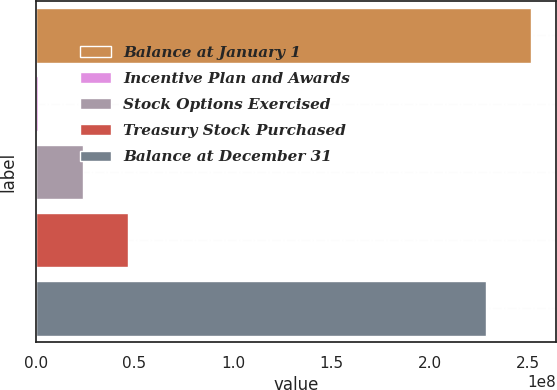Convert chart. <chart><loc_0><loc_0><loc_500><loc_500><bar_chart><fcel>Balance at January 1<fcel>Incentive Plan and Awards<fcel>Stock Options Exercised<fcel>Treasury Stock Purchased<fcel>Balance at December 31<nl><fcel>2.51414e+08<fcel>1.20912e+06<fcel>2.40176e+07<fcel>4.68261e+07<fcel>2.28605e+08<nl></chart> 